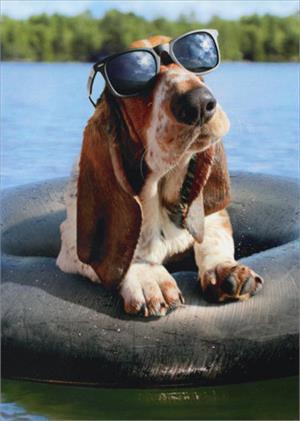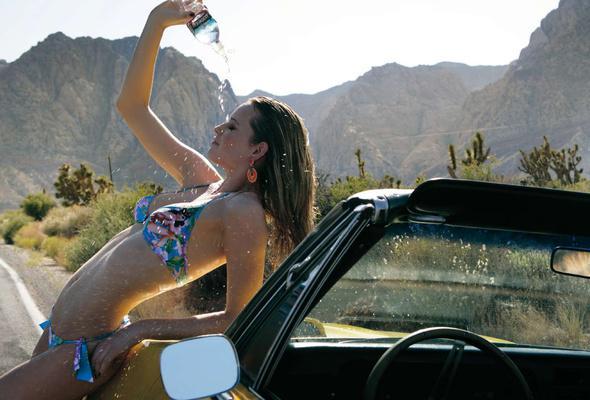The first image is the image on the left, the second image is the image on the right. Given the left and right images, does the statement "In one of the images there is a Basset Hound wearing sunglasses." hold true? Answer yes or no. Yes. 